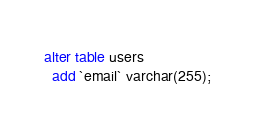Convert code to text. <code><loc_0><loc_0><loc_500><loc_500><_SQL_>alter table users
  add `email` varchar(255);</code> 